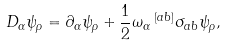Convert formula to latex. <formula><loc_0><loc_0><loc_500><loc_500>D _ { \alpha } \psi _ { \rho } = \partial _ { \alpha } \psi _ { \rho } + \frac { 1 } { 2 } \omega _ { \alpha } \, ^ { \left [ a b \right ] } \sigma _ { a b } \psi _ { \rho } ,</formula> 